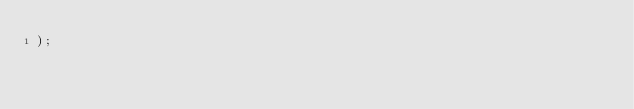<code> <loc_0><loc_0><loc_500><loc_500><_SQL_>);
</code> 